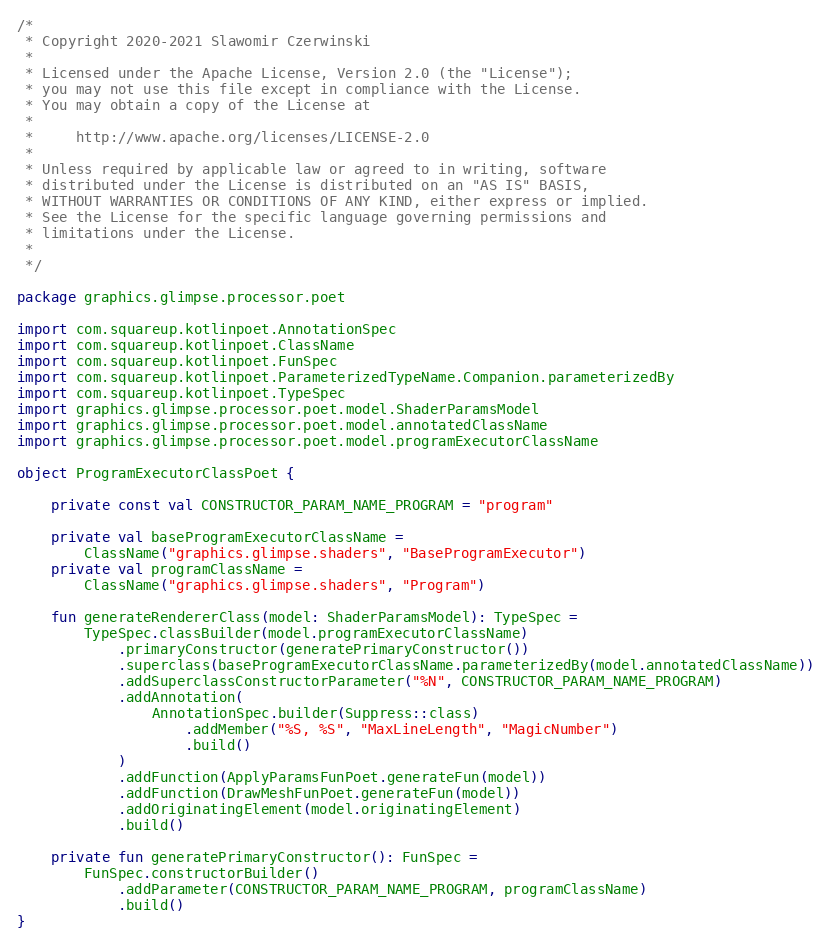Convert code to text. <code><loc_0><loc_0><loc_500><loc_500><_Kotlin_>/*
 * Copyright 2020-2021 Slawomir Czerwinski
 *
 * Licensed under the Apache License, Version 2.0 (the "License");
 * you may not use this file except in compliance with the License.
 * You may obtain a copy of the License at
 *
 *     http://www.apache.org/licenses/LICENSE-2.0
 *
 * Unless required by applicable law or agreed to in writing, software
 * distributed under the License is distributed on an "AS IS" BASIS,
 * WITHOUT WARRANTIES OR CONDITIONS OF ANY KIND, either express or implied.
 * See the License for the specific language governing permissions and
 * limitations under the License.
 *
 */

package graphics.glimpse.processor.poet

import com.squareup.kotlinpoet.AnnotationSpec
import com.squareup.kotlinpoet.ClassName
import com.squareup.kotlinpoet.FunSpec
import com.squareup.kotlinpoet.ParameterizedTypeName.Companion.parameterizedBy
import com.squareup.kotlinpoet.TypeSpec
import graphics.glimpse.processor.poet.model.ShaderParamsModel
import graphics.glimpse.processor.poet.model.annotatedClassName
import graphics.glimpse.processor.poet.model.programExecutorClassName

object ProgramExecutorClassPoet {

    private const val CONSTRUCTOR_PARAM_NAME_PROGRAM = "program"

    private val baseProgramExecutorClassName =
        ClassName("graphics.glimpse.shaders", "BaseProgramExecutor")
    private val programClassName =
        ClassName("graphics.glimpse.shaders", "Program")

    fun generateRendererClass(model: ShaderParamsModel): TypeSpec =
        TypeSpec.classBuilder(model.programExecutorClassName)
            .primaryConstructor(generatePrimaryConstructor())
            .superclass(baseProgramExecutorClassName.parameterizedBy(model.annotatedClassName))
            .addSuperclassConstructorParameter("%N", CONSTRUCTOR_PARAM_NAME_PROGRAM)
            .addAnnotation(
                AnnotationSpec.builder(Suppress::class)
                    .addMember("%S, %S", "MaxLineLength", "MagicNumber")
                    .build()
            )
            .addFunction(ApplyParamsFunPoet.generateFun(model))
            .addFunction(DrawMeshFunPoet.generateFun(model))
            .addOriginatingElement(model.originatingElement)
            .build()

    private fun generatePrimaryConstructor(): FunSpec =
        FunSpec.constructorBuilder()
            .addParameter(CONSTRUCTOR_PARAM_NAME_PROGRAM, programClassName)
            .build()
}
</code> 